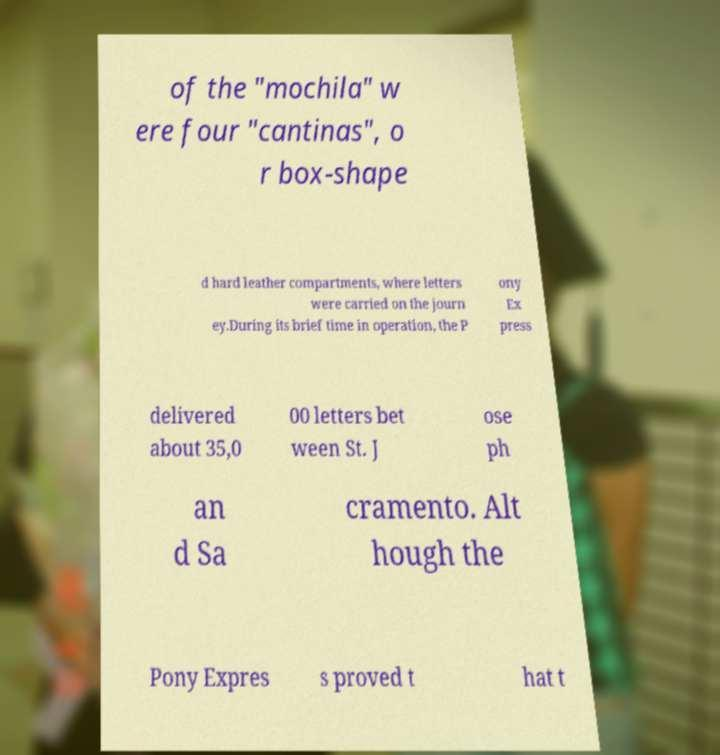Please read and relay the text visible in this image. What does it say? of the "mochila" w ere four "cantinas", o r box-shape d hard leather compartments, where letters were carried on the journ ey.During its brief time in operation, the P ony Ex press delivered about 35,0 00 letters bet ween St. J ose ph an d Sa cramento. Alt hough the Pony Expres s proved t hat t 